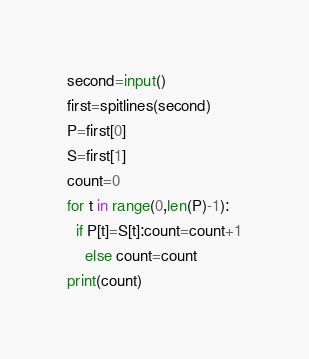Convert code to text. <code><loc_0><loc_0><loc_500><loc_500><_Python_>second=input()
first=spitlines(second)
P=first[0]
S=first[1]
count=0
for t in range(0,len(P)-1):
  if P[t]=S[t]:count=count+1
    else count=count
print(count)</code> 